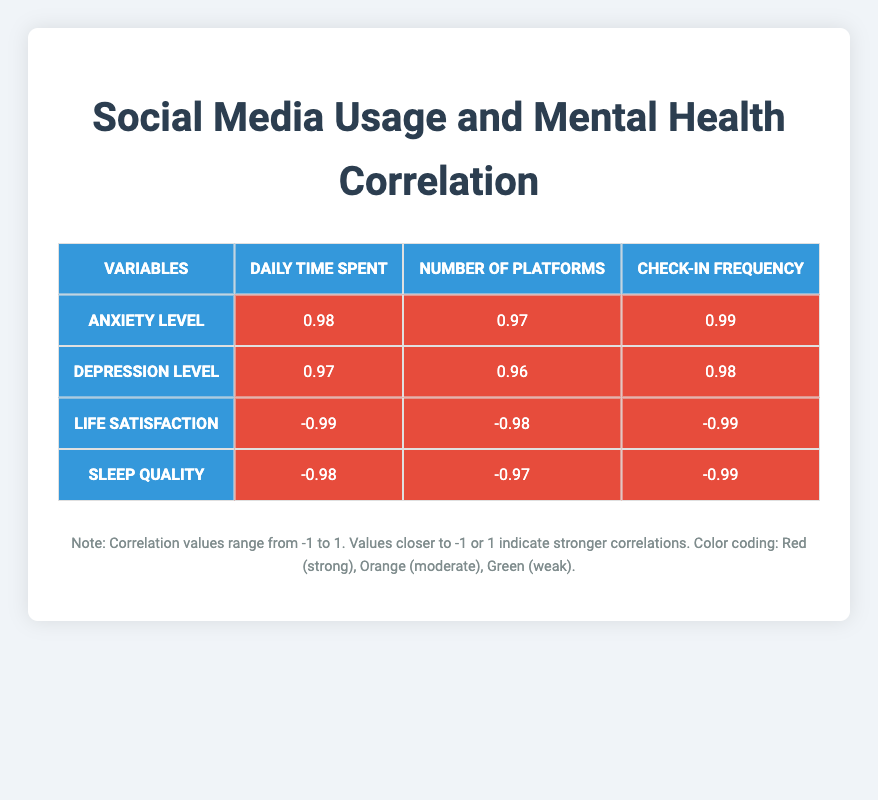What is the correlation between daily time spent on social media and self-reported anxiety level? The table indicates a correlation of 0.98 between daily time spent on social media and self-reported anxiety level, which signifies a very strong positive relationship.
Answer: 0.98 What is the correlation between the number of social media platforms used and self-reported depression level? The correlation value provided in the table is 0.96, showing a strong positive correlation between the number of platforms used and self-reported depression level.
Answer: 0.96 Is there a correlation between frequency of social media check-ins per day and overall life satisfaction score? Yes, the table shows a correlation of -0.99, indicating a strong negative relationship; as check-ins increase, overall life satisfaction decreases.
Answer: Yes What is the average correlation value for sleep quality score across all social media usage metrics? To find the average, sum the correlation values for sleep quality (which are -0.98, -0.97, -0.99) and divide by 3. The total is -2.94, and the average is -2.94/3, which equals -0.98.
Answer: -0.98 What is the correlation between the number of social media platforms used and daily time spent on social media? The table lists a correlation of 0.97 between the number of platforms used and daily time spent on social media, indicating a very strong positive relationship.
Answer: 0.97 Does higher frequency of social media check-ins correlate positively or negatively with self-reported anxiety level? It correlates positively; the table shows a correlation of 0.99, meaning that increased check-ins are associated with higher anxiety levels.
Answer: Positively What is the strongest correlation from the table and with which mental health indicator? The strongest correlation is with self-reported anxiety levels and frequency of social media check-ins per day, with a value of 0.99.
Answer: 0.99 with anxiety level What is the difference in correlation values between sleep quality and overall life satisfaction metrics for daily time spent? The correlation for sleep quality is -0.98, and for overall life satisfaction, it is -0.99. The difference is calculated as -0.99 - (-0.98) = -0.01.
Answer: -0.01 